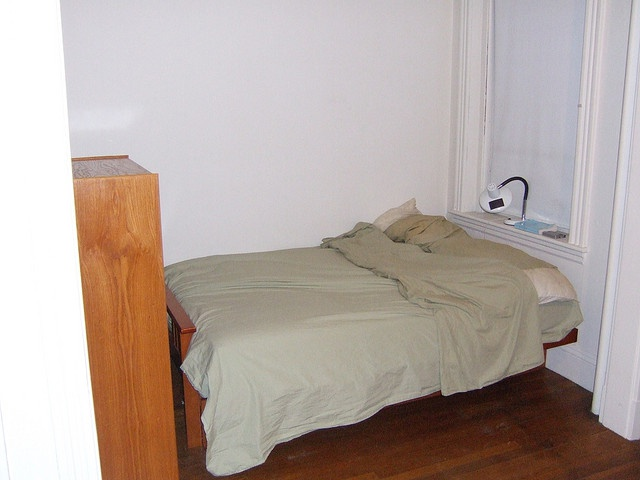Describe the objects in this image and their specific colors. I can see a bed in white, darkgray, and gray tones in this image. 